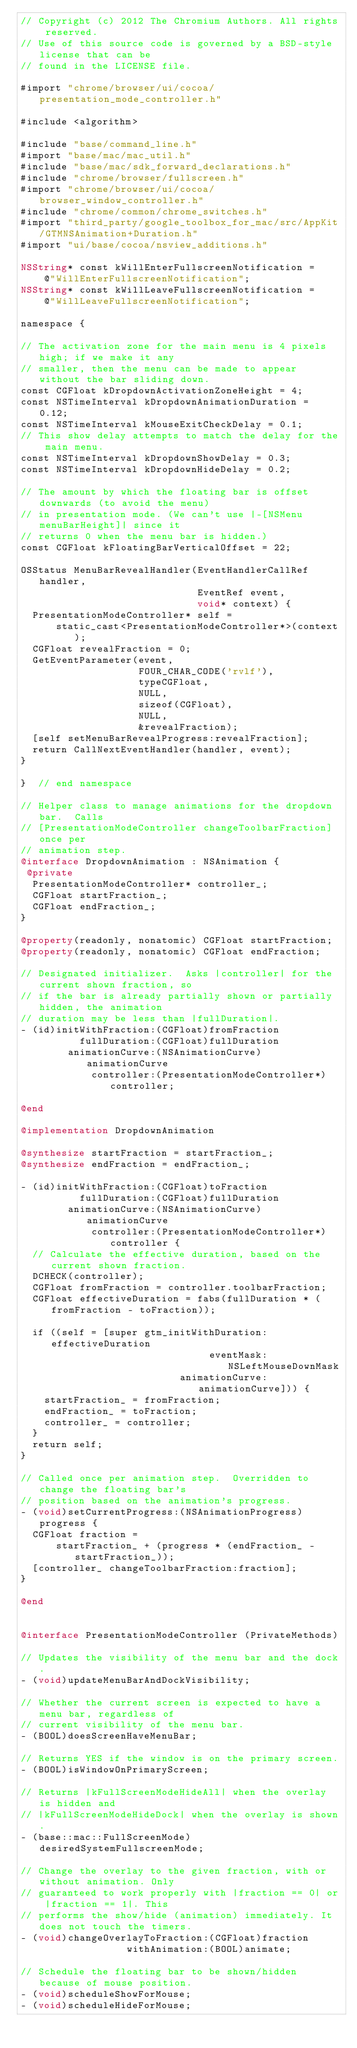<code> <loc_0><loc_0><loc_500><loc_500><_ObjectiveC_>// Copyright (c) 2012 The Chromium Authors. All rights reserved.
// Use of this source code is governed by a BSD-style license that can be
// found in the LICENSE file.

#import "chrome/browser/ui/cocoa/presentation_mode_controller.h"

#include <algorithm>

#include "base/command_line.h"
#import "base/mac/mac_util.h"
#include "base/mac/sdk_forward_declarations.h"
#include "chrome/browser/fullscreen.h"
#import "chrome/browser/ui/cocoa/browser_window_controller.h"
#include "chrome/common/chrome_switches.h"
#import "third_party/google_toolbox_for_mac/src/AppKit/GTMNSAnimation+Duration.h"
#import "ui/base/cocoa/nsview_additions.h"

NSString* const kWillEnterFullscreenNotification =
    @"WillEnterFullscreenNotification";
NSString* const kWillLeaveFullscreenNotification =
    @"WillLeaveFullscreenNotification";

namespace {

// The activation zone for the main menu is 4 pixels high; if we make it any
// smaller, then the menu can be made to appear without the bar sliding down.
const CGFloat kDropdownActivationZoneHeight = 4;
const NSTimeInterval kDropdownAnimationDuration = 0.12;
const NSTimeInterval kMouseExitCheckDelay = 0.1;
// This show delay attempts to match the delay for the main menu.
const NSTimeInterval kDropdownShowDelay = 0.3;
const NSTimeInterval kDropdownHideDelay = 0.2;

// The amount by which the floating bar is offset downwards (to avoid the menu)
// in presentation mode. (We can't use |-[NSMenu menuBarHeight]| since it
// returns 0 when the menu bar is hidden.)
const CGFloat kFloatingBarVerticalOffset = 22;

OSStatus MenuBarRevealHandler(EventHandlerCallRef handler,
                              EventRef event,
                              void* context) {
  PresentationModeController* self =
      static_cast<PresentationModeController*>(context);
  CGFloat revealFraction = 0;
  GetEventParameter(event,
                    FOUR_CHAR_CODE('rvlf'),
                    typeCGFloat,
                    NULL,
                    sizeof(CGFloat),
                    NULL,
                    &revealFraction);
  [self setMenuBarRevealProgress:revealFraction];
  return CallNextEventHandler(handler, event);
}

}  // end namespace

// Helper class to manage animations for the dropdown bar.  Calls
// [PresentationModeController changeToolbarFraction] once per
// animation step.
@interface DropdownAnimation : NSAnimation {
 @private
  PresentationModeController* controller_;
  CGFloat startFraction_;
  CGFloat endFraction_;
}

@property(readonly, nonatomic) CGFloat startFraction;
@property(readonly, nonatomic) CGFloat endFraction;

// Designated initializer.  Asks |controller| for the current shown fraction, so
// if the bar is already partially shown or partially hidden, the animation
// duration may be less than |fullDuration|.
- (id)initWithFraction:(CGFloat)fromFraction
          fullDuration:(CGFloat)fullDuration
        animationCurve:(NSAnimationCurve)animationCurve
            controller:(PresentationModeController*)controller;

@end

@implementation DropdownAnimation

@synthesize startFraction = startFraction_;
@synthesize endFraction = endFraction_;

- (id)initWithFraction:(CGFloat)toFraction
          fullDuration:(CGFloat)fullDuration
        animationCurve:(NSAnimationCurve)animationCurve
            controller:(PresentationModeController*)controller {
  // Calculate the effective duration, based on the current shown fraction.
  DCHECK(controller);
  CGFloat fromFraction = controller.toolbarFraction;
  CGFloat effectiveDuration = fabs(fullDuration * (fromFraction - toFraction));

  if ((self = [super gtm_initWithDuration:effectiveDuration
                                eventMask:NSLeftMouseDownMask
                           animationCurve:animationCurve])) {
    startFraction_ = fromFraction;
    endFraction_ = toFraction;
    controller_ = controller;
  }
  return self;
}

// Called once per animation step.  Overridden to change the floating bar's
// position based on the animation's progress.
- (void)setCurrentProgress:(NSAnimationProgress)progress {
  CGFloat fraction =
      startFraction_ + (progress * (endFraction_ - startFraction_));
  [controller_ changeToolbarFraction:fraction];
}

@end


@interface PresentationModeController (PrivateMethods)

// Updates the visibility of the menu bar and the dock.
- (void)updateMenuBarAndDockVisibility;

// Whether the current screen is expected to have a menu bar, regardless of
// current visibility of the menu bar.
- (BOOL)doesScreenHaveMenuBar;

// Returns YES if the window is on the primary screen.
- (BOOL)isWindowOnPrimaryScreen;

// Returns |kFullScreenModeHideAll| when the overlay is hidden and
// |kFullScreenModeHideDock| when the overlay is shown.
- (base::mac::FullScreenMode)desiredSystemFullscreenMode;

// Change the overlay to the given fraction, with or without animation. Only
// guaranteed to work properly with |fraction == 0| or |fraction == 1|. This
// performs the show/hide (animation) immediately. It does not touch the timers.
- (void)changeOverlayToFraction:(CGFloat)fraction
                  withAnimation:(BOOL)animate;

// Schedule the floating bar to be shown/hidden because of mouse position.
- (void)scheduleShowForMouse;
- (void)scheduleHideForMouse;
</code> 